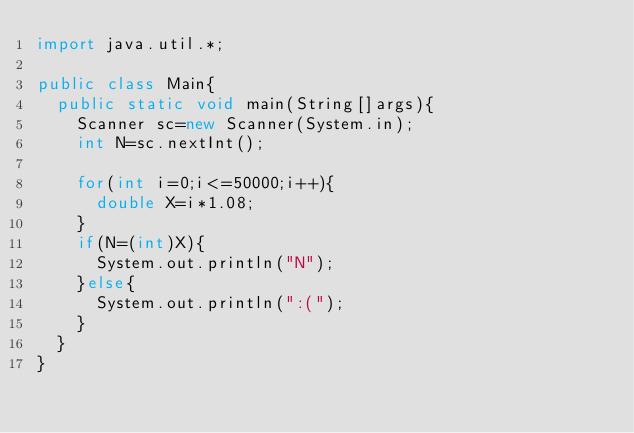Convert code to text. <code><loc_0><loc_0><loc_500><loc_500><_Java_>import java.util.*;

public class Main{
  public static void main(String[]args){
    Scanner sc=new Scanner(System.in);
    int N=sc.nextInt();
    
    for(int i=0;i<=50000;i++){
      double X=i*1.08;
    }
    if(N=(int)X){
      System.out.println("N");
    }else{
      System.out.println(":(");
    }
  }
}
</code> 